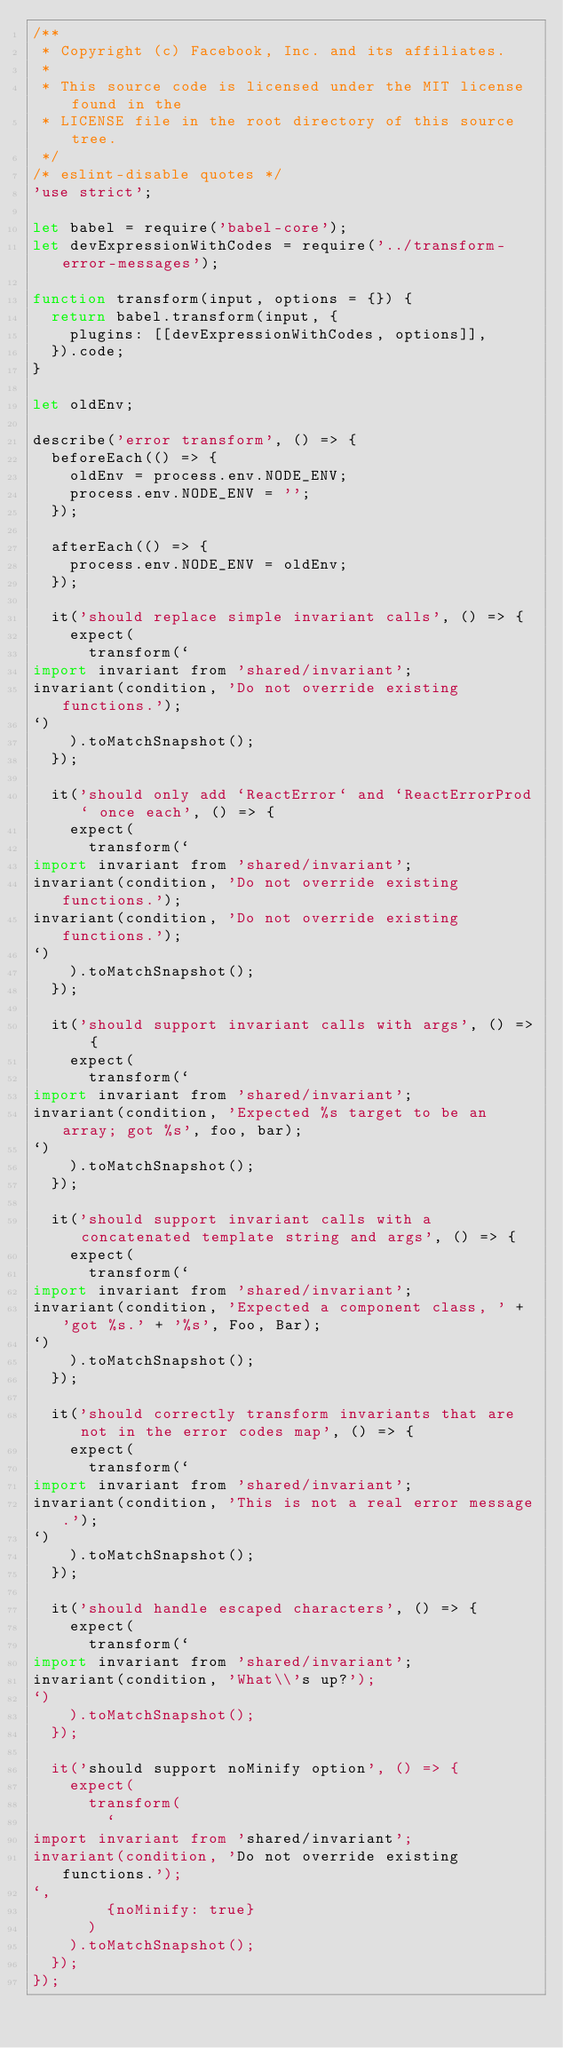<code> <loc_0><loc_0><loc_500><loc_500><_JavaScript_>/**
 * Copyright (c) Facebook, Inc. and its affiliates.
 *
 * This source code is licensed under the MIT license found in the
 * LICENSE file in the root directory of this source tree.
 */
/* eslint-disable quotes */
'use strict';

let babel = require('babel-core');
let devExpressionWithCodes = require('../transform-error-messages');

function transform(input, options = {}) {
  return babel.transform(input, {
    plugins: [[devExpressionWithCodes, options]],
  }).code;
}

let oldEnv;

describe('error transform', () => {
  beforeEach(() => {
    oldEnv = process.env.NODE_ENV;
    process.env.NODE_ENV = '';
  });

  afterEach(() => {
    process.env.NODE_ENV = oldEnv;
  });

  it('should replace simple invariant calls', () => {
    expect(
      transform(`
import invariant from 'shared/invariant';
invariant(condition, 'Do not override existing functions.');
`)
    ).toMatchSnapshot();
  });

  it('should only add `ReactError` and `ReactErrorProd` once each', () => {
    expect(
      transform(`
import invariant from 'shared/invariant';
invariant(condition, 'Do not override existing functions.');
invariant(condition, 'Do not override existing functions.');
`)
    ).toMatchSnapshot();
  });

  it('should support invariant calls with args', () => {
    expect(
      transform(`
import invariant from 'shared/invariant';
invariant(condition, 'Expected %s target to be an array; got %s', foo, bar);
`)
    ).toMatchSnapshot();
  });

  it('should support invariant calls with a concatenated template string and args', () => {
    expect(
      transform(`
import invariant from 'shared/invariant';
invariant(condition, 'Expected a component class, ' + 'got %s.' + '%s', Foo, Bar);
`)
    ).toMatchSnapshot();
  });

  it('should correctly transform invariants that are not in the error codes map', () => {
    expect(
      transform(`
import invariant from 'shared/invariant';
invariant(condition, 'This is not a real error message.');
`)
    ).toMatchSnapshot();
  });

  it('should handle escaped characters', () => {
    expect(
      transform(`
import invariant from 'shared/invariant';
invariant(condition, 'What\\'s up?');
`)
    ).toMatchSnapshot();
  });

  it('should support noMinify option', () => {
    expect(
      transform(
        `
import invariant from 'shared/invariant';
invariant(condition, 'Do not override existing functions.');
`,
        {noMinify: true}
      )
    ).toMatchSnapshot();
  });
});
</code> 